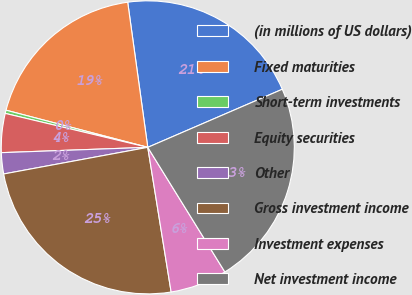Convert chart. <chart><loc_0><loc_0><loc_500><loc_500><pie_chart><fcel>(in millions of US dollars)<fcel>Fixed maturities<fcel>Short-term investments<fcel>Equity securities<fcel>Other<fcel>Gross investment income<fcel>Investment expenses<fcel>Net investment income<nl><fcel>20.7%<fcel>18.73%<fcel>0.36%<fcel>4.3%<fcel>2.33%<fcel>24.64%<fcel>6.27%<fcel>22.67%<nl></chart> 